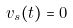<formula> <loc_0><loc_0><loc_500><loc_500>v _ { s } ( t ) = 0</formula> 